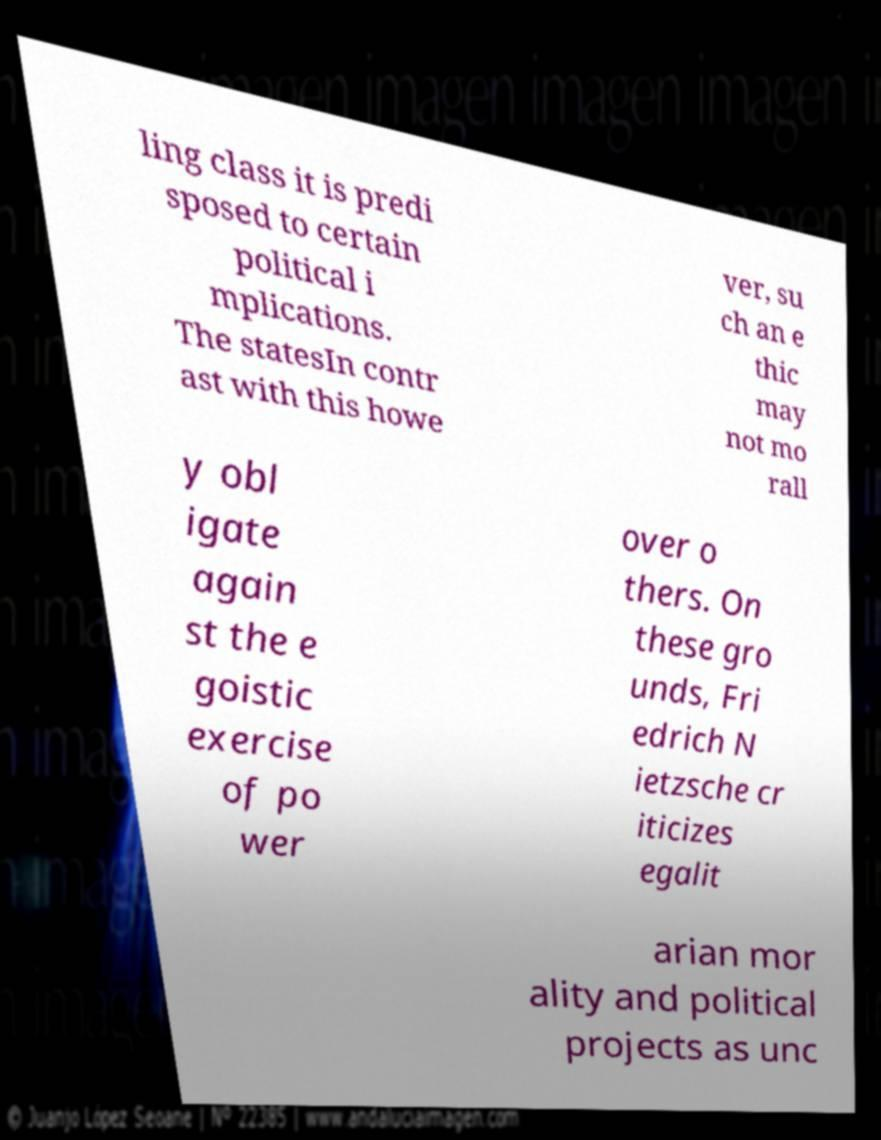What messages or text are displayed in this image? I need them in a readable, typed format. ling class it is predi sposed to certain political i mplications. The statesIn contr ast with this howe ver, su ch an e thic may not mo rall y obl igate again st the e goistic exercise of po wer over o thers. On these gro unds, Fri edrich N ietzsche cr iticizes egalit arian mor ality and political projects as unc 